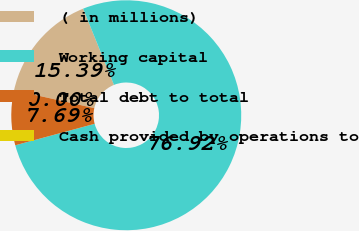Convert chart. <chart><loc_0><loc_0><loc_500><loc_500><pie_chart><fcel>( in millions)<fcel>Working capital<fcel>Total debt to total<fcel>Cash provided by operations to<nl><fcel>15.39%<fcel>76.92%<fcel>7.69%<fcel>0.0%<nl></chart> 